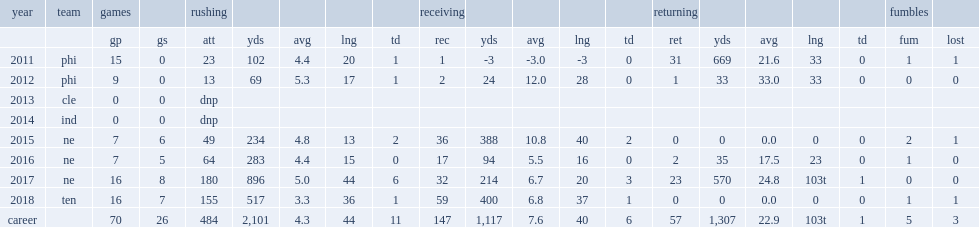How many rushing yards did lewis get in 2018? 517.0. 